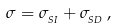Convert formula to latex. <formula><loc_0><loc_0><loc_500><loc_500>\sigma = \sigma _ { _ { S I } } + \sigma _ { _ { S D } } \, ,</formula> 